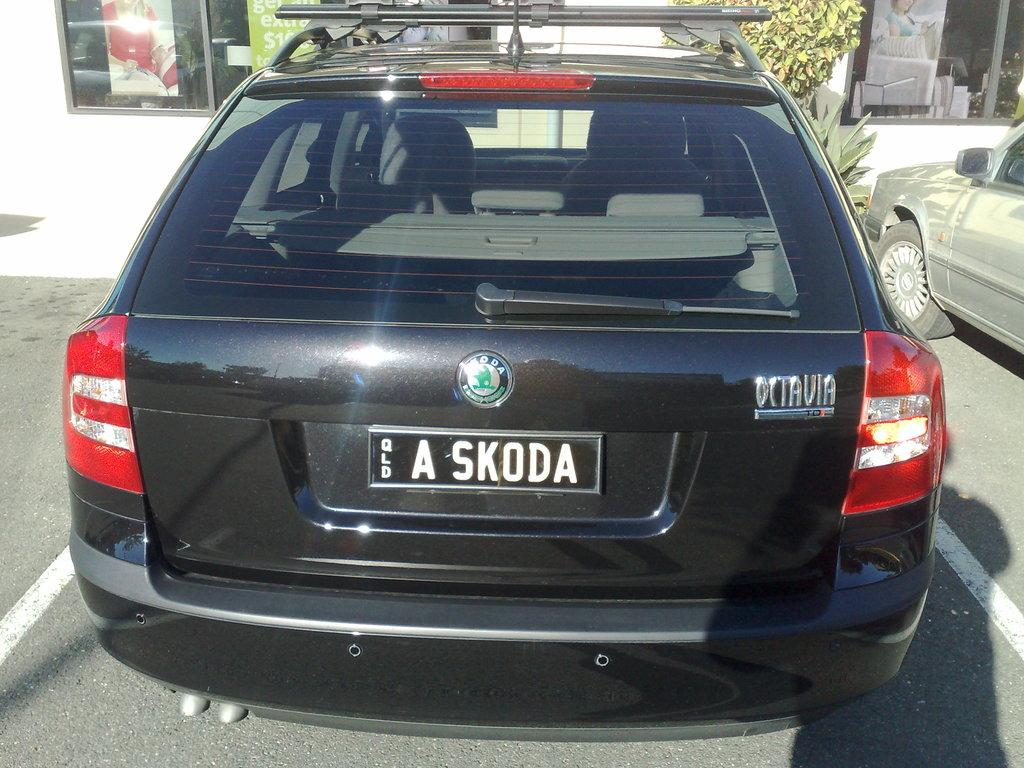<image>
Offer a succinct explanation of the picture presented. A black car that says Octavia on the back right. 